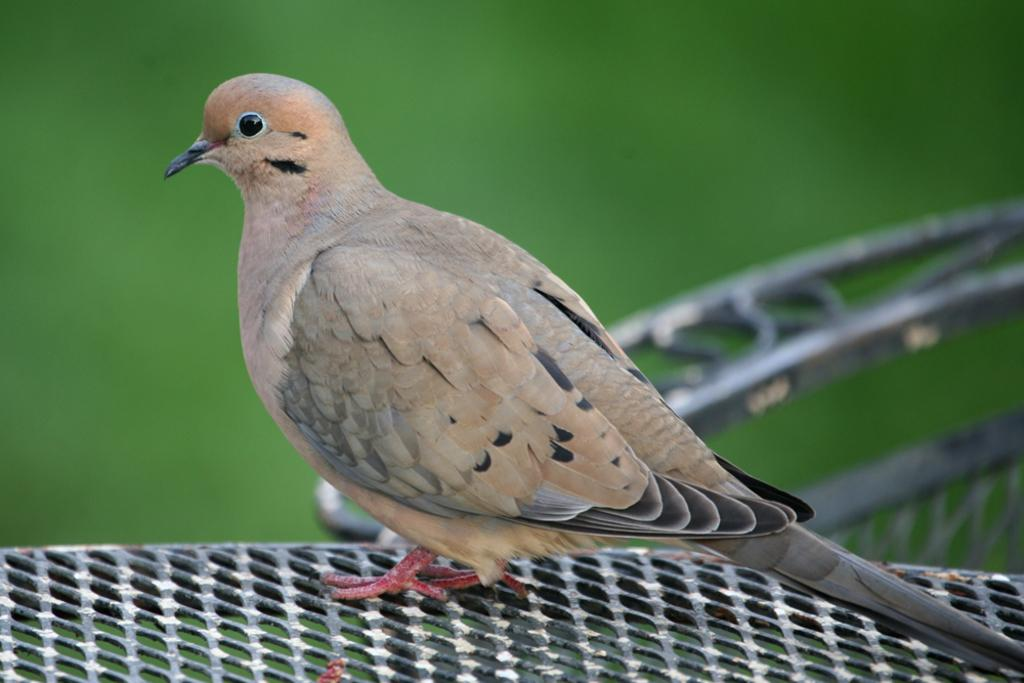What is the main subject in the center of the image? There is a bird in the center of the image. What can be seen at the bottom of the image? There is a mesh at the bottom of the image. What type of party is being held in the image? There is no party present in the image; it features a bird and a mesh. What is the topic of the discussion taking place in the image? There is no discussion present in the image; it features a bird and a mesh. 